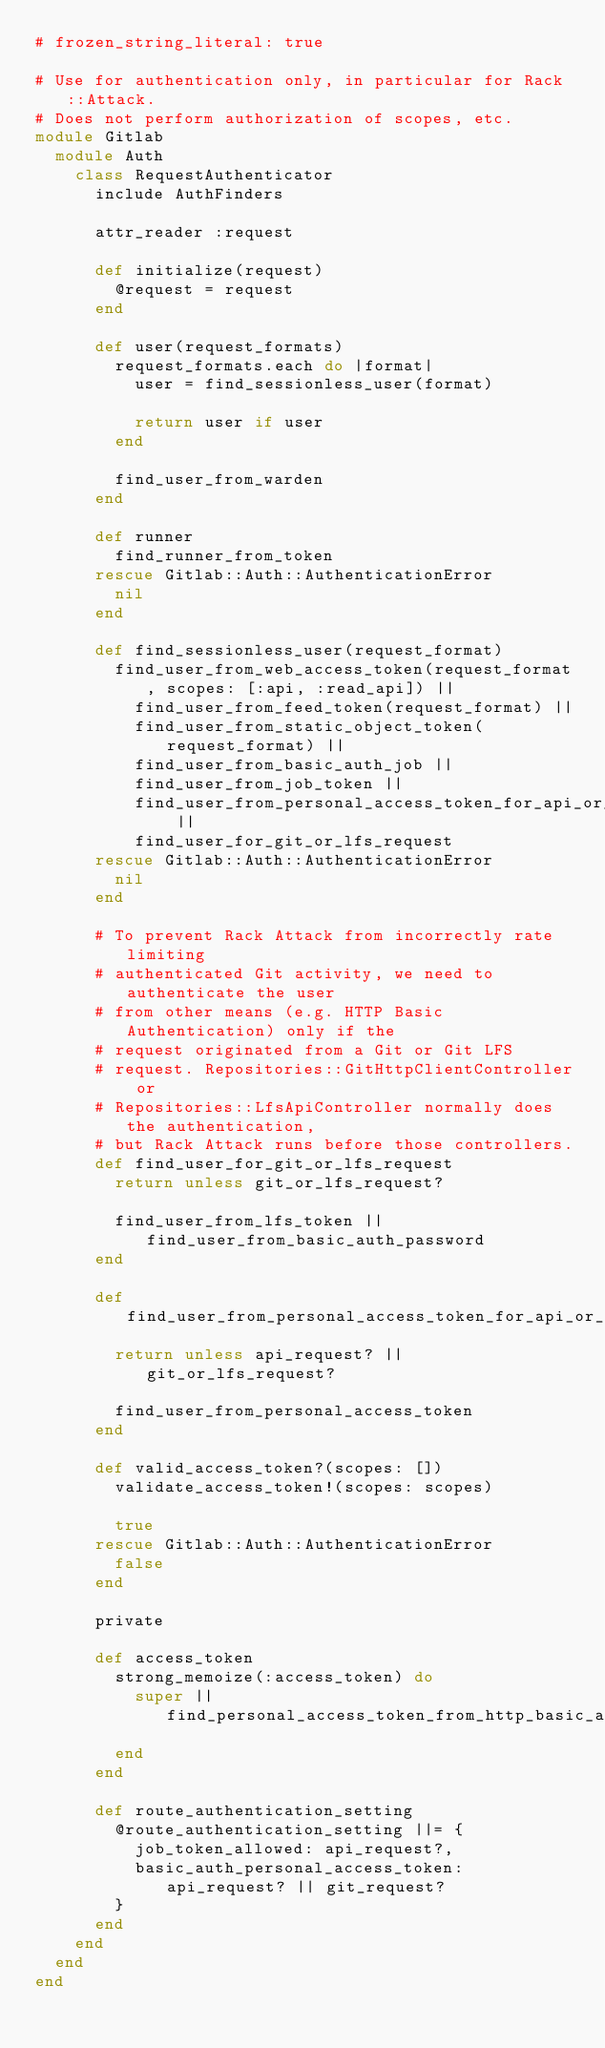<code> <loc_0><loc_0><loc_500><loc_500><_Ruby_># frozen_string_literal: true

# Use for authentication only, in particular for Rack::Attack.
# Does not perform authorization of scopes, etc.
module Gitlab
  module Auth
    class RequestAuthenticator
      include AuthFinders

      attr_reader :request

      def initialize(request)
        @request = request
      end

      def user(request_formats)
        request_formats.each do |format|
          user = find_sessionless_user(format)

          return user if user
        end

        find_user_from_warden
      end

      def runner
        find_runner_from_token
      rescue Gitlab::Auth::AuthenticationError
        nil
      end

      def find_sessionless_user(request_format)
        find_user_from_web_access_token(request_format, scopes: [:api, :read_api]) ||
          find_user_from_feed_token(request_format) ||
          find_user_from_static_object_token(request_format) ||
          find_user_from_basic_auth_job ||
          find_user_from_job_token ||
          find_user_from_personal_access_token_for_api_or_git ||
          find_user_for_git_or_lfs_request
      rescue Gitlab::Auth::AuthenticationError
        nil
      end

      # To prevent Rack Attack from incorrectly rate limiting
      # authenticated Git activity, we need to authenticate the user
      # from other means (e.g. HTTP Basic Authentication) only if the
      # request originated from a Git or Git LFS
      # request. Repositories::GitHttpClientController or
      # Repositories::LfsApiController normally does the authentication,
      # but Rack Attack runs before those controllers.
      def find_user_for_git_or_lfs_request
        return unless git_or_lfs_request?

        find_user_from_lfs_token || find_user_from_basic_auth_password
      end

      def find_user_from_personal_access_token_for_api_or_git
        return unless api_request? || git_or_lfs_request?

        find_user_from_personal_access_token
      end

      def valid_access_token?(scopes: [])
        validate_access_token!(scopes: scopes)

        true
      rescue Gitlab::Auth::AuthenticationError
        false
      end

      private

      def access_token
        strong_memoize(:access_token) do
          super || find_personal_access_token_from_http_basic_auth
        end
      end

      def route_authentication_setting
        @route_authentication_setting ||= {
          job_token_allowed: api_request?,
          basic_auth_personal_access_token: api_request? || git_request?
        }
      end
    end
  end
end
</code> 